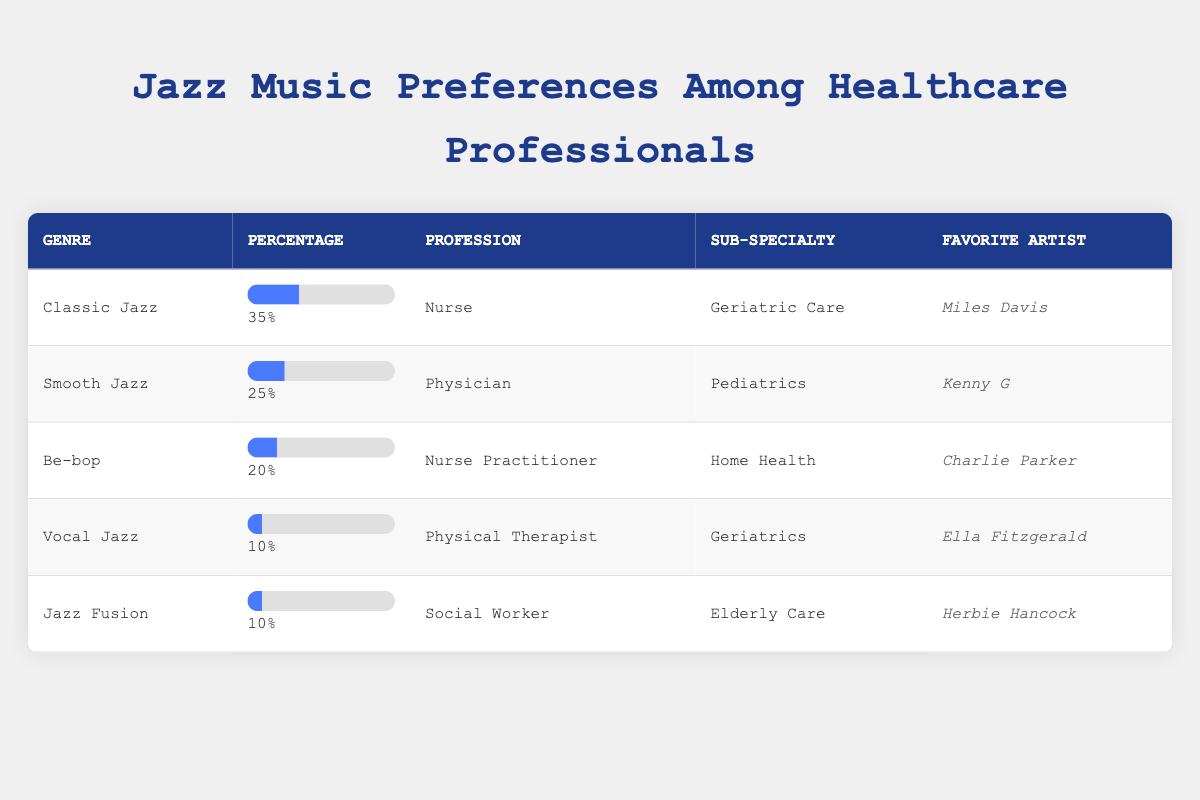What is the most preferred genre of jazz music among healthcare professionals? In the table, the percentages for jazz genres are listed alongside the genres themselves. The highest percentage, 35%, is for "Classic Jazz," which indicates it is the most preferred genre among the healthcare professionals surveyed.
Answer: Classic Jazz Which profession has a preference for Smooth Jazz? From the table, Smooth Jazz is listed next to "Physician," which identifies this profession as the one with a preference for this genre.
Answer: Physician What percentage of healthcare professionals prefer Vocal Jazz? The table indicates that Vocal Jazz has a percentage of 10%. This is a straightforward retrieval from the data.
Answer: 10% If you sum the percentages of Classic Jazz and Be-bop, what do you get? The percentages for Classic Jazz and Be-bop are 35% and 20%, respectively. Adding these gives 35 + 20 = 55%.
Answer: 55% Is there a healthcare professional who prefers Jazz Fusion? The data shows that "Social Worker" is listed as preferring Jazz Fusion, indicating that there is indeed a healthcare professional with this preference.
Answer: Yes Which favorite artist is associated with the highest percentage of jazz preference? The table lists "Miles Davis" with Classic Jazz, which has the highest percentage of 35%. This artist is therefore associated with the highest preference among all the data points.
Answer: Miles Davis What is the difference in percentage between the most and least preferred jazz genres? The most preferred genre is Classic Jazz at 35% and the least preferred genres, Vocal Jazz and Jazz Fusion, are both at 10%. The difference can be calculated as 35 - 10 = 25%.
Answer: 25% Are there more healthcare professionals who prefer Be-bop compared to Vocal Jazz? Be-bop has a percentage of 20%, while Vocal Jazz has a percentage of 10%. Since 20% is greater than 10%, the answer is yes.
Answer: Yes How many jazz genres have a percentage of 10%? From the table, Vocal Jazz and Jazz Fusion both have a percentage of 10%. This indicates there are two genres with this preference level.
Answer: 2 